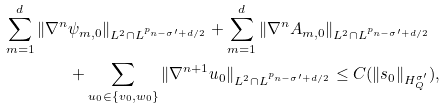Convert formula to latex. <formula><loc_0><loc_0><loc_500><loc_500>\sum _ { m = 1 } ^ { d } \| \nabla ^ { n } & \psi _ { m , 0 } \| _ { L ^ { 2 } \cap L ^ { p _ { n - \sigma ^ { \prime } + d / 2 } } } + \sum _ { m = 1 } ^ { d } \| \nabla ^ { n } A _ { m , 0 } \| _ { L ^ { 2 } \cap L ^ { p _ { n - \sigma ^ { \prime } + d / 2 } } } \\ & + \sum _ { u _ { 0 } \in \{ v _ { 0 } , w _ { 0 } \} } \| \nabla ^ { n + 1 } u _ { 0 } \| _ { L ^ { 2 } \cap L ^ { p _ { n - \sigma ^ { \prime } + d / 2 } } } \leq C ( \| s _ { 0 } \| _ { H ^ { \sigma ^ { \prime } } _ { Q } } ) ,</formula> 